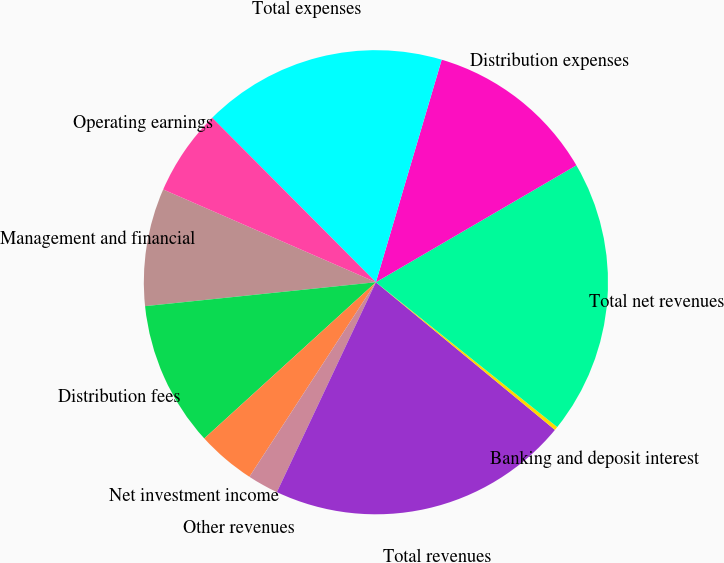Convert chart to OTSL. <chart><loc_0><loc_0><loc_500><loc_500><pie_chart><fcel>Management and financial<fcel>Distribution fees<fcel>Net investment income<fcel>Other revenues<fcel>Total revenues<fcel>Banking and deposit interest<fcel>Total net revenues<fcel>Distribution expenses<fcel>Total expenses<fcel>Operating earnings<nl><fcel>8.19%<fcel>10.11%<fcel>4.07%<fcel>2.16%<fcel>21.04%<fcel>0.25%<fcel>19.13%<fcel>12.02%<fcel>17.04%<fcel>5.99%<nl></chart> 